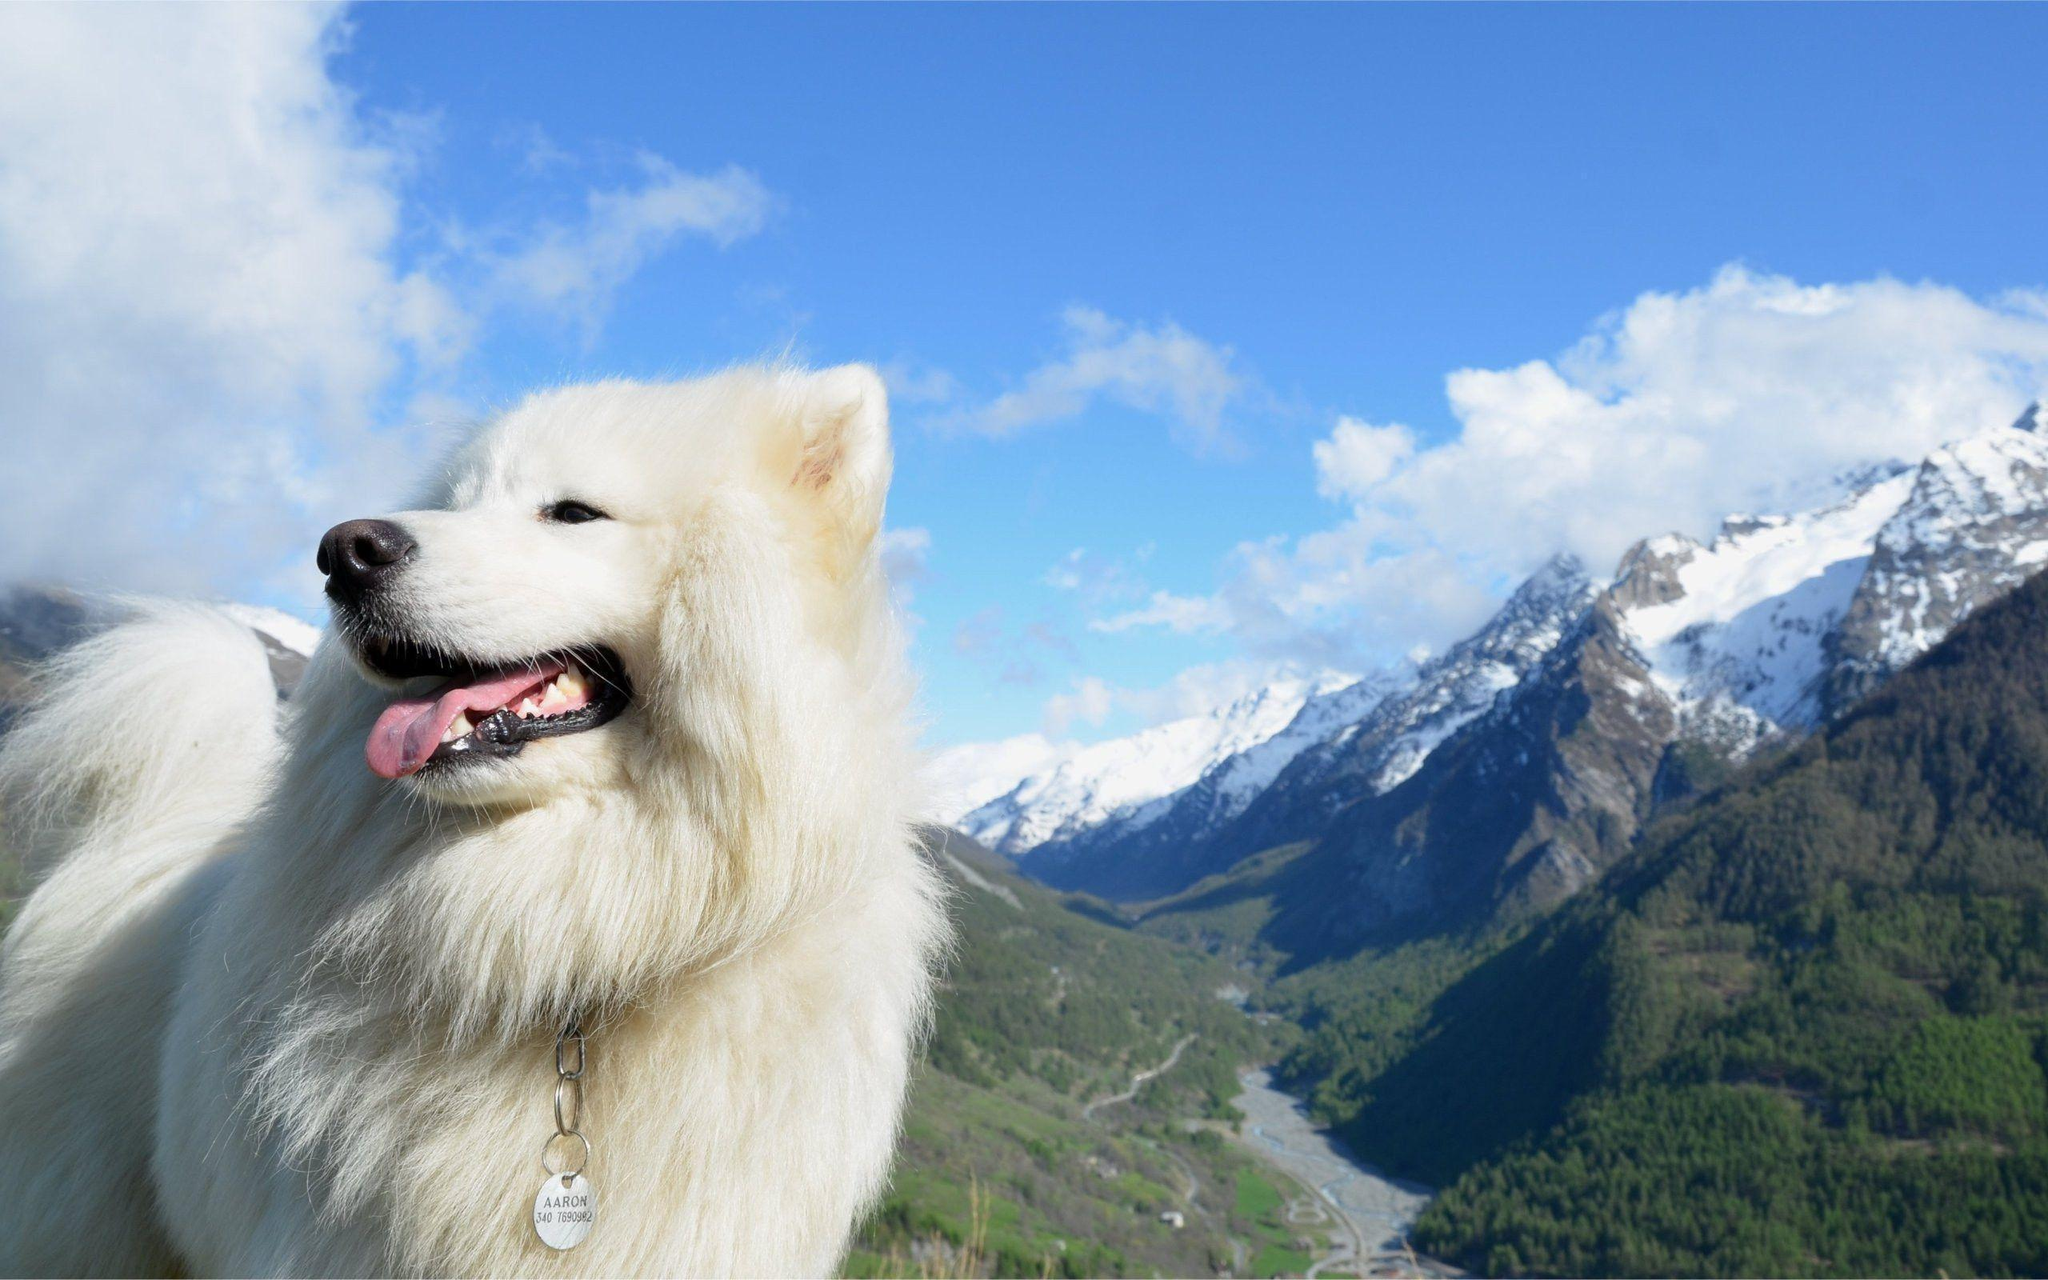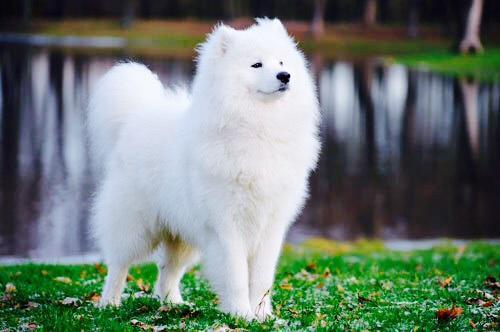The first image is the image on the left, the second image is the image on the right. Evaluate the accuracy of this statement regarding the images: "The right image contains a white dog facing towards the right.". Is it true? Answer yes or no. Yes. 